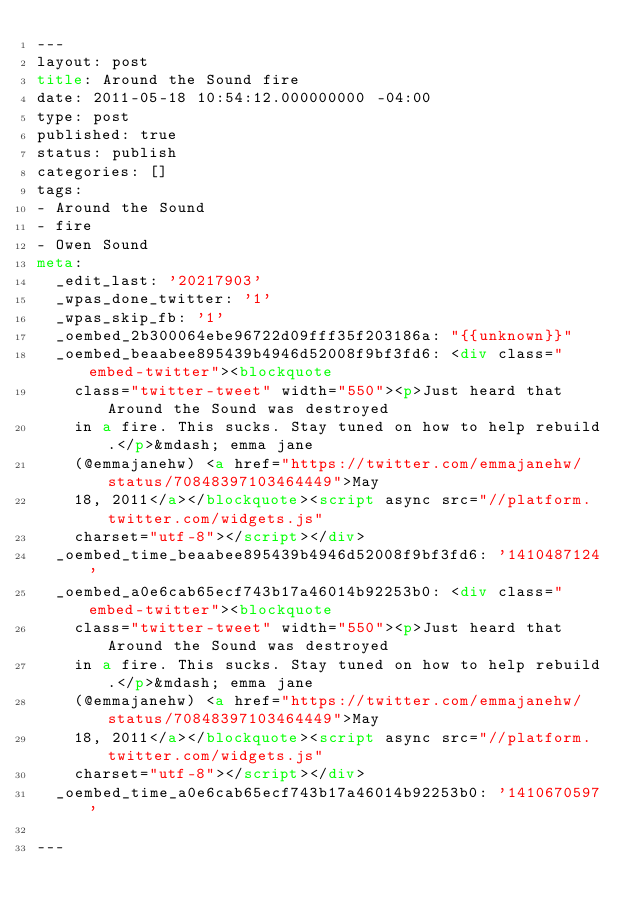<code> <loc_0><loc_0><loc_500><loc_500><_HTML_>---
layout: post
title: Around the Sound fire
date: 2011-05-18 10:54:12.000000000 -04:00
type: post
published: true
status: publish
categories: []
tags:
- Around the Sound
- fire
- Owen Sound
meta:
  _edit_last: '20217903'
  _wpas_done_twitter: '1'
  _wpas_skip_fb: '1'
  _oembed_2b300064ebe96722d09fff35f203186a: "{{unknown}}"
  _oembed_beaabee895439b4946d52008f9bf3fd6: <div class="embed-twitter"><blockquote
    class="twitter-tweet" width="550"><p>Just heard that Around the Sound was destroyed
    in a fire. This sucks. Stay tuned on how to help rebuild.</p>&mdash; emma jane
    (@emmajanehw) <a href="https://twitter.com/emmajanehw/status/70848397103464449">May
    18, 2011</a></blockquote><script async src="//platform.twitter.com/widgets.js"
    charset="utf-8"></script></div>
  _oembed_time_beaabee895439b4946d52008f9bf3fd6: '1410487124'
  _oembed_a0e6cab65ecf743b17a46014b92253b0: <div class="embed-twitter"><blockquote
    class="twitter-tweet" width="550"><p>Just heard that Around the Sound was destroyed
    in a fire. This sucks. Stay tuned on how to help rebuild.</p>&mdash; emma jane
    (@emmajanehw) <a href="https://twitter.com/emmajanehw/status/70848397103464449">May
    18, 2011</a></blockquote><script async src="//platform.twitter.com/widgets.js"
    charset="utf-8"></script></div>
  _oembed_time_a0e6cab65ecf743b17a46014b92253b0: '1410670597'

---</code> 